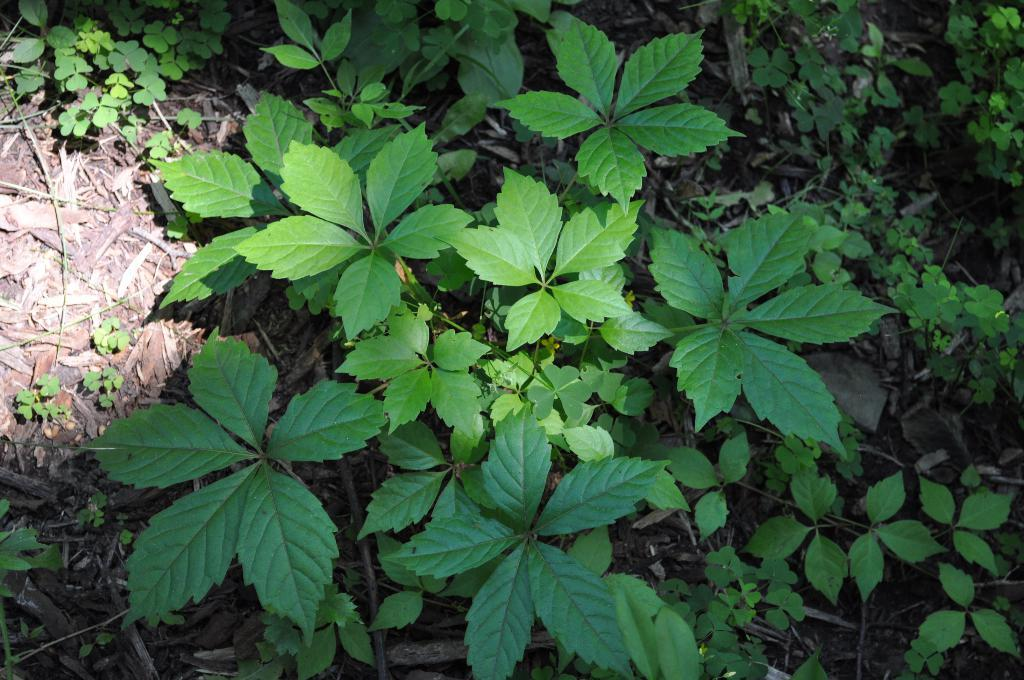What type of living organisms can be seen in the image? Plants can be seen in the image. What color is the gold that the plants are crying in the image? There is no gold or crying plants present in the image; it only features plants. 